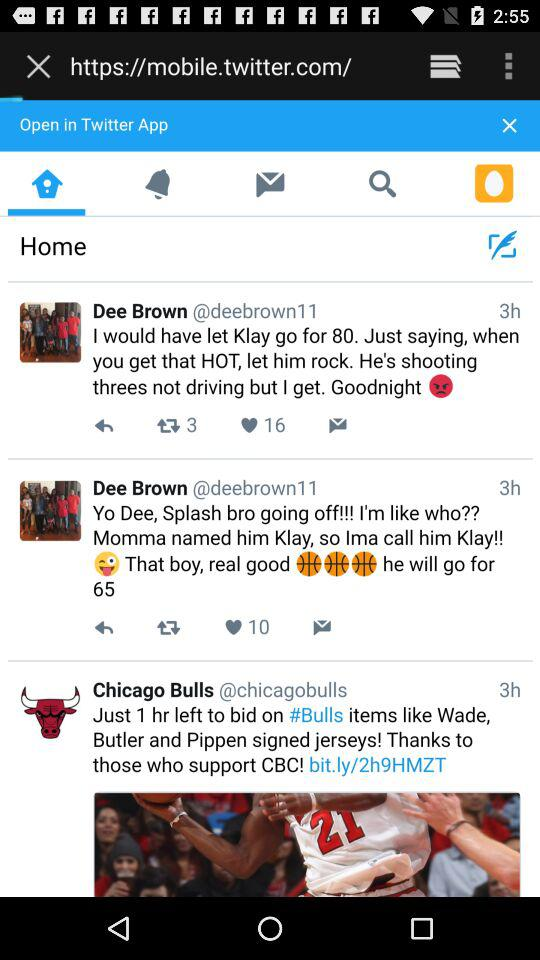How many likes are there on Dee Brown's post?
When the provided information is insufficient, respond with <no answer>. <no answer> 